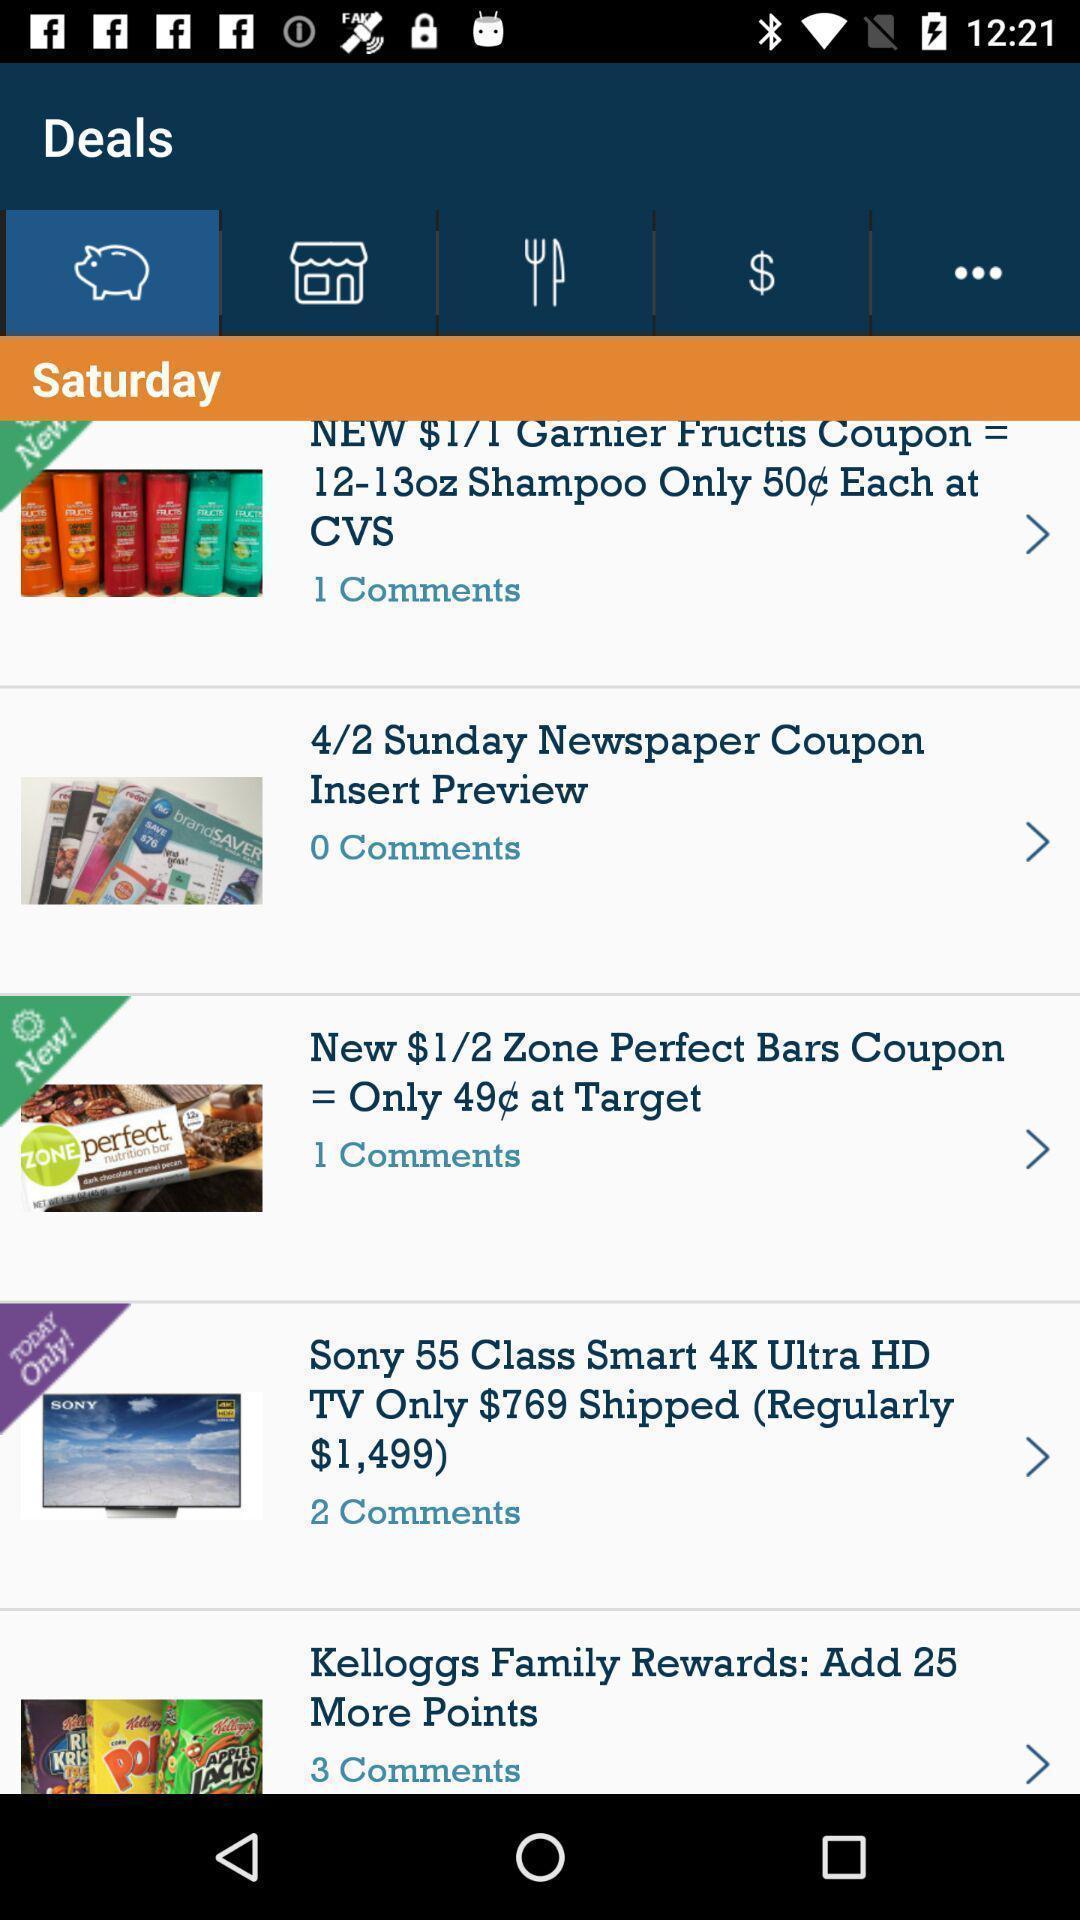What can you discern from this picture? Screen display deals page in a shopping app. 